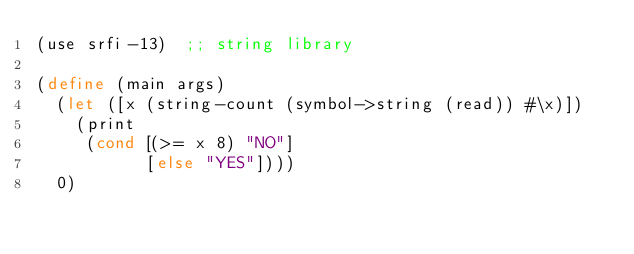<code> <loc_0><loc_0><loc_500><loc_500><_Scheme_>(use srfi-13)  ;; string library

(define (main args)
  (let ([x (string-count (symbol->string (read)) #\x)])
    (print
     (cond [(>= x 8) "NO"]
           [else "YES"])))
  0)
</code> 